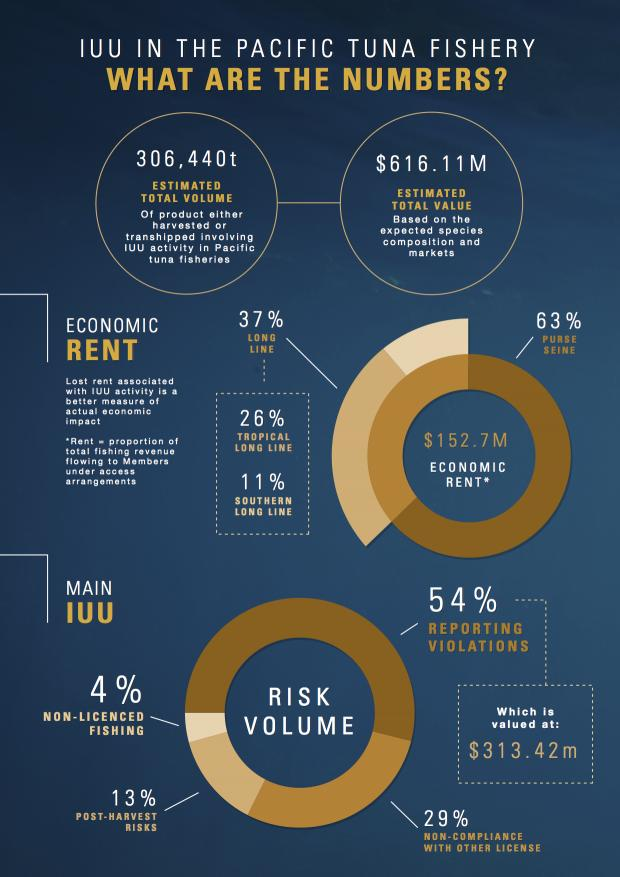Identify some key points in this picture. Tropical long lines contribute to a higher percentage of long line economic rent compared to other categories of long lines. The risk of violations being reported is significantly higher for fishing vessels that are not licensed, at approximately 50%. After the harvest, post-harvest risks have the second lowest volume of risk, making it a safe and reliable option for farmers and traders. The categories of long line economic rent are tropical long line and southern long line. There are two types of economic rents: long lines and purse sienes. 